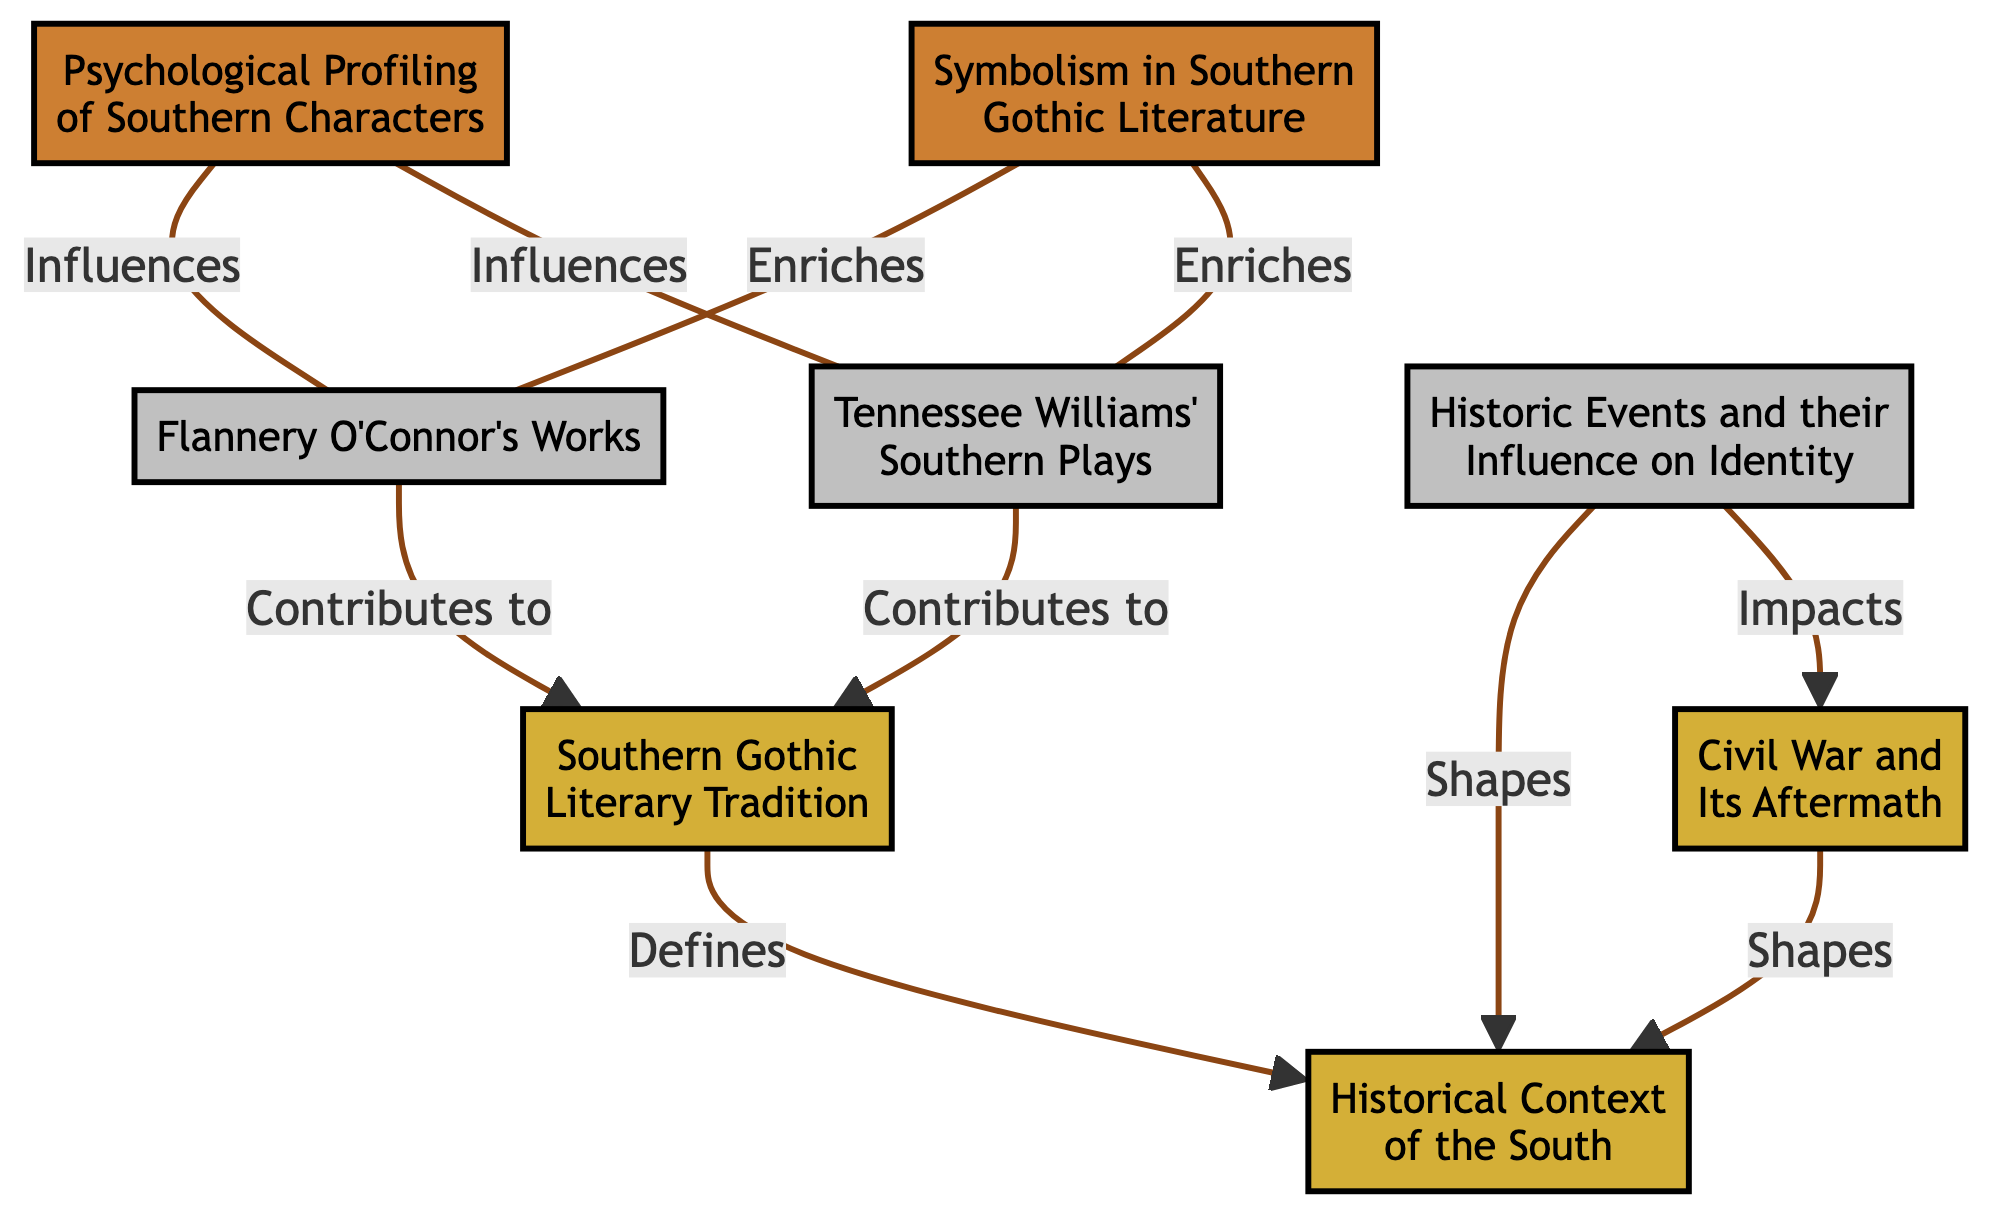What is the most general element in the diagram? The most general element is at the bottom, showing the broadest historical context, which is "Historical Context of the South."
Answer: Historical Context of the South How many specific elements are there in the diagram? Counting the elements marked as "Specific," there are three: Flannery O'Connor's Works, Tennessee Williams' Southern Plays, and Historic Events and their Influence on Identity.
Answer: 3 What do the detailed elements enrich? The detailed elements "Psychological Profiling of Southern Characters" and "Symbolism in Southern Gothic Literature" both enrich "Flannery O'Connor's Works" and "Tennessee Williams' Southern Plays."
Answer: Flannery O'Connor's Works and Tennessee Williams' Southern Plays Which element shapes the historical context according to the diagram? The element that shapes the historical context is "Civil War and Its Aftermath," as it is directly linked to "Historical Context of the South."
Answer: Civil War and Its Aftermath How are the general elements of the Civil War related to the historical context? The general element "Civil War and Its Aftermath" shapes the broad historical context, meaning it provides a foundational aspect to understand the South's identity.
Answer: Shapes What specific themes do Flannery O'Connor's works contribute to in Southern Gothic literature? Flannery O'Connor's works contribute themes such as isolation, despair, and grotesque elements to Southern Gothic literature.
Answer: Southern Gothic themes What influences the psychological profiling of Southern characters? The psychological profiling is influenced by both "Flannery O'Connor's Works" and "Tennessee Williams' Southern Plays."
Answer: Flannery O'Connor's Works and Tennessee Williams' Southern Plays How many detailed elements are included in the diagram? There are two detailed elements indicated in the diagram: Psychological Profiling of Southern Characters and Symbolism in Southern Gothic Literature.
Answer: 2 Which elements are influenced by historic events in the context? "Historic Events and their Influence on Identity" shapes "Historical Context of the South" and impacts "Civil War and Its Aftermath."
Answer: Historical Context of the South and Civil War and Its Aftermath 